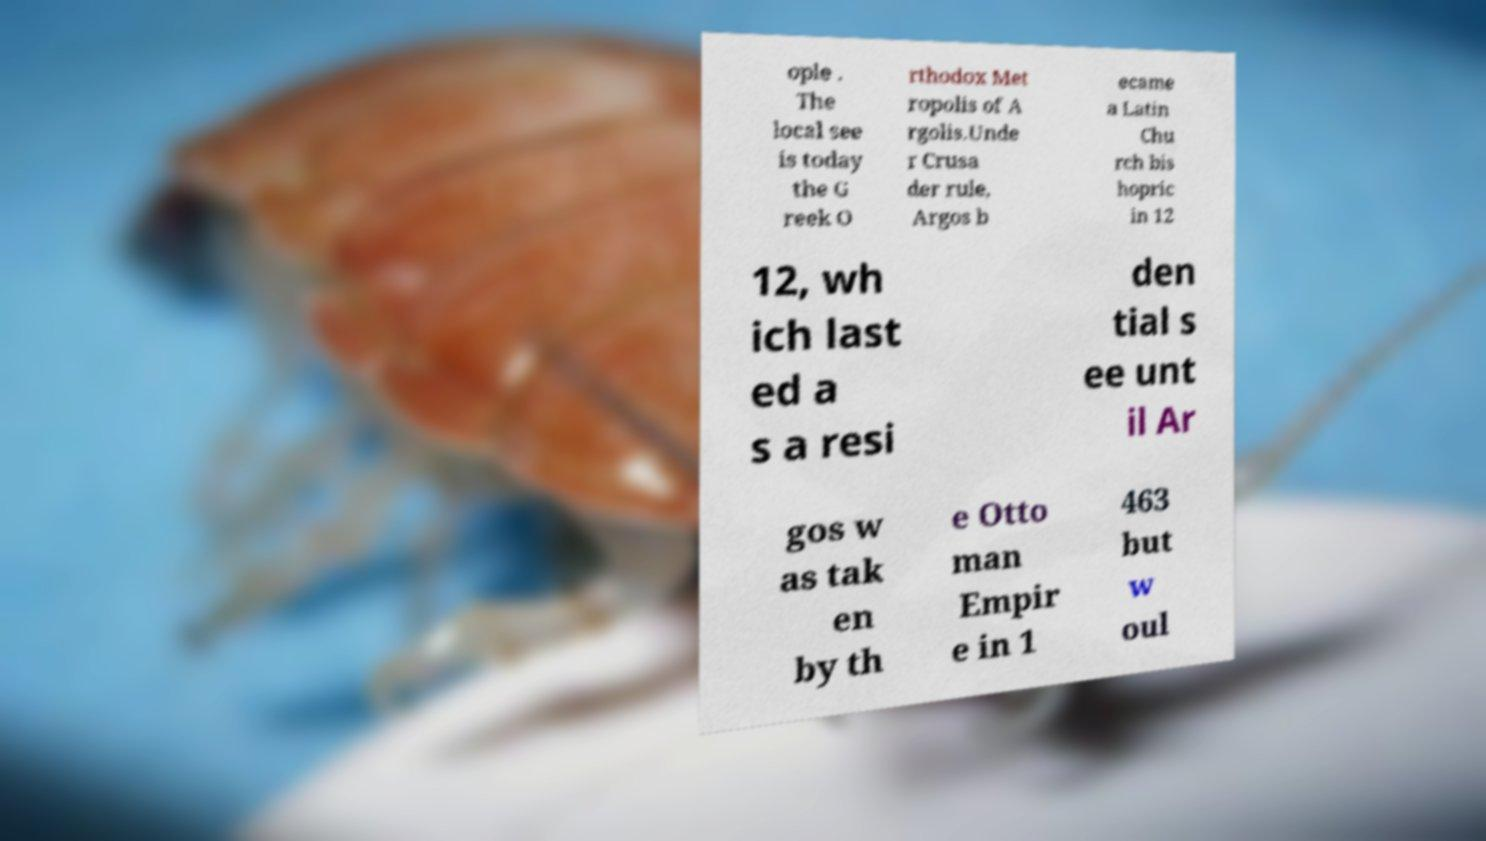What messages or text are displayed in this image? I need them in a readable, typed format. ople . The local see is today the G reek O rthodox Met ropolis of A rgolis.Unde r Crusa der rule, Argos b ecame a Latin Chu rch bis hopric in 12 12, wh ich last ed a s a resi den tial s ee unt il Ar gos w as tak en by th e Otto man Empir e in 1 463 but w oul 